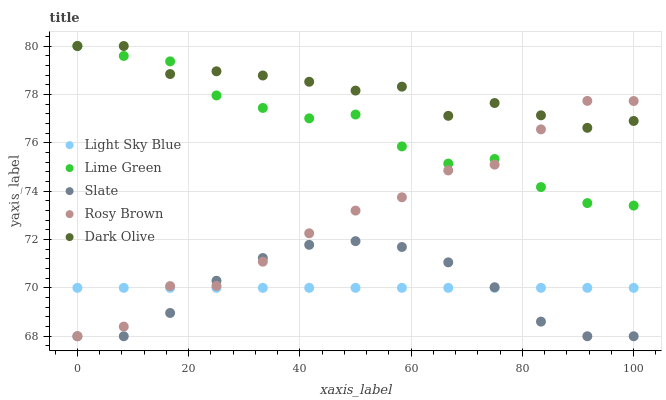Does Slate have the minimum area under the curve?
Answer yes or no. Yes. Does Dark Olive have the maximum area under the curve?
Answer yes or no. Yes. Does Light Sky Blue have the minimum area under the curve?
Answer yes or no. No. Does Light Sky Blue have the maximum area under the curve?
Answer yes or no. No. Is Light Sky Blue the smoothest?
Answer yes or no. Yes. Is Rosy Brown the roughest?
Answer yes or no. Yes. Is Slate the smoothest?
Answer yes or no. No. Is Slate the roughest?
Answer yes or no. No. Does Slate have the lowest value?
Answer yes or no. Yes. Does Light Sky Blue have the lowest value?
Answer yes or no. No. Does Lime Green have the highest value?
Answer yes or no. Yes. Does Slate have the highest value?
Answer yes or no. No. Is Light Sky Blue less than Dark Olive?
Answer yes or no. Yes. Is Dark Olive greater than Light Sky Blue?
Answer yes or no. Yes. Does Dark Olive intersect Rosy Brown?
Answer yes or no. Yes. Is Dark Olive less than Rosy Brown?
Answer yes or no. No. Is Dark Olive greater than Rosy Brown?
Answer yes or no. No. Does Light Sky Blue intersect Dark Olive?
Answer yes or no. No. 